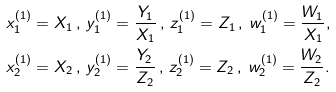<formula> <loc_0><loc_0><loc_500><loc_500>& { x _ { 1 } ^ { ( 1 ) } } = X _ { 1 } \, , \, { y _ { 1 } ^ { ( 1 ) } } = \frac { Y _ { 1 } } { X _ { 1 } } \, , \, { z _ { 1 } ^ { ( 1 ) } } = Z _ { 1 } \, , \, { w _ { 1 } ^ { ( 1 ) } } = \frac { W _ { 1 } } { X _ { 1 } } , \\ & { x _ { 2 } ^ { ( 1 ) } } = X _ { 2 } \, , \, { y _ { 2 } ^ { ( 1 ) } } = \frac { Y _ { 2 } } { Z _ { 2 } } \, , \, { z _ { 2 } ^ { ( 1 ) } } = Z _ { 2 } \, , \, { w _ { 2 } ^ { ( 1 ) } } = \frac { W _ { 2 } } { Z _ { 2 } } .</formula> 